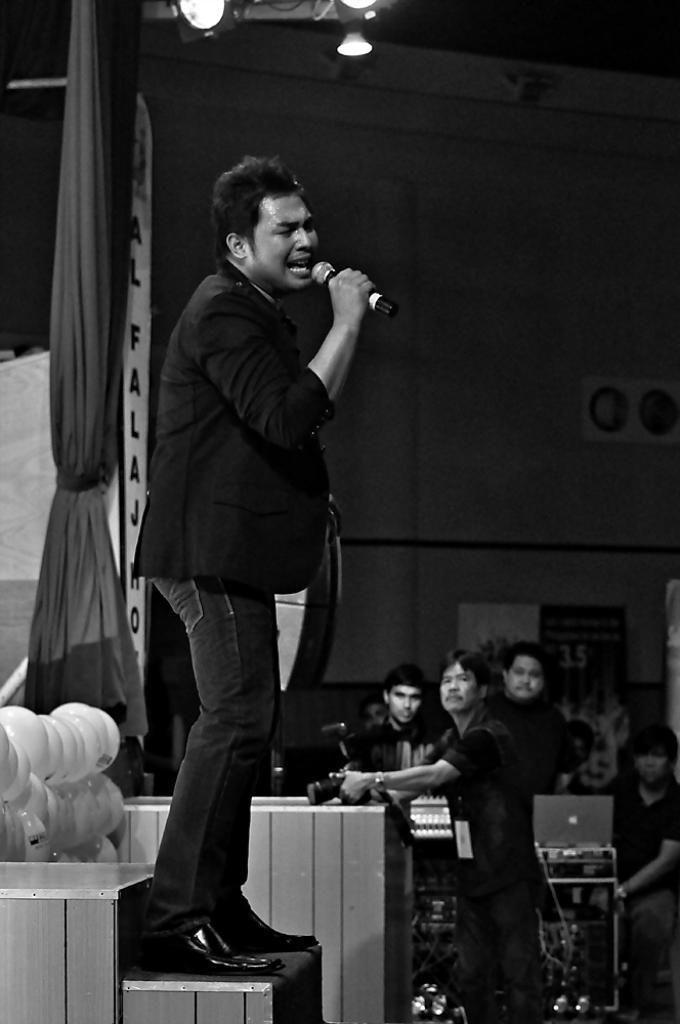Describe this image in one or two sentences. This is a black and white image. On the left side, I can see a man standing on the stage, holding a mike in the hand and singing. He is facing towards the right side. At the back of this man I can see few balloons and a curtain. In the background there are few persons standing and looking at this man. At the top of the image I can see the wall and few lights. 